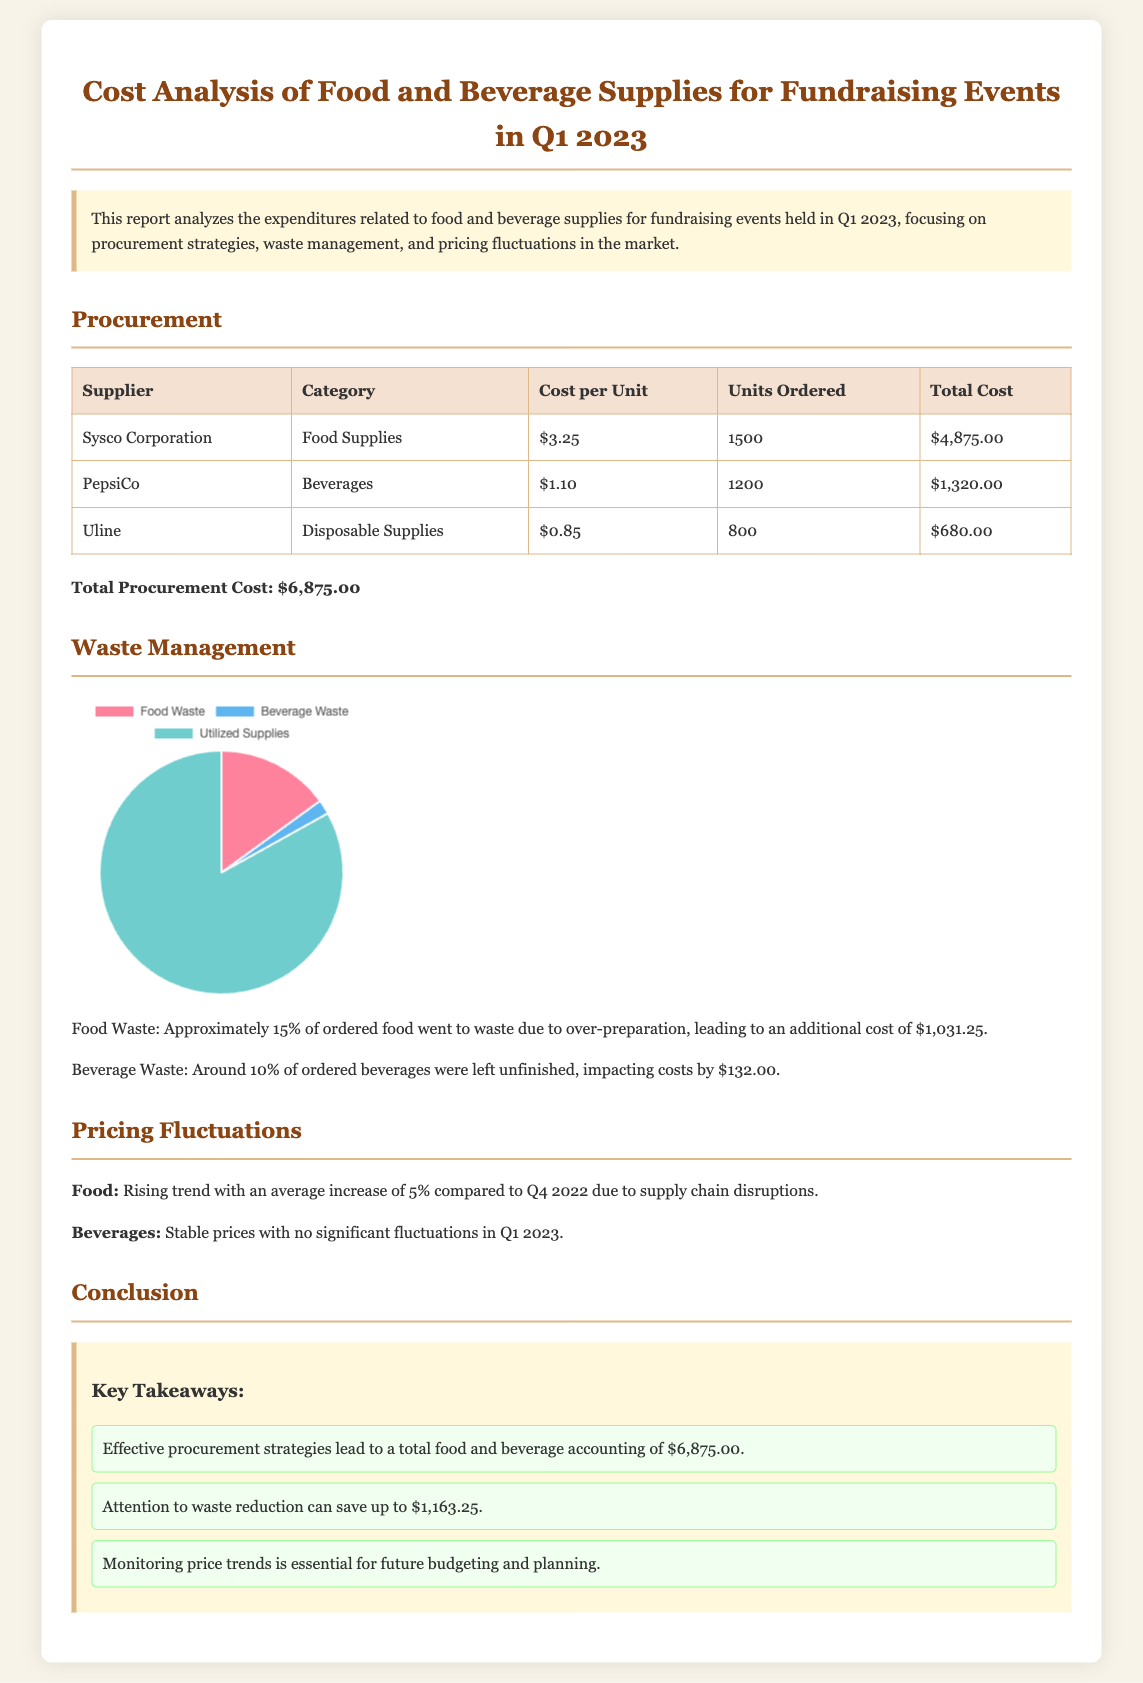What is the total procurement cost? The total procurement cost is explicitly stated in the document under the procurement section.
Answer: $6,875.00 What percentage of food went to waste? The document specifies that approximately 15% of the ordered food went to waste due to over-preparation.
Answer: 15% Who was the supplier for beverages? The document lists the supplier for beverages, which is mentioned in the procurement section.
Answer: PepsiCo What is the average increase in food pricing compared to Q4 2022? The report indicates that there is a rising trend in food prices with an average increase specified.
Answer: 5% How much was lost due to food waste? The cost attributed to food waste is highlighted in the waste management section of the report.
Answer: $1,031.25 What does the waste management chart represent? The chart visually displays the distribution of food waste, beverage waste, and utilized supplies, summarizing waste management data in a graphical format.
Answer: Waste vs Utilized Supplies What is the cost of disposable supplies per unit? This cost is detailed in the procurement table for disposable supplies.
Answer: $0.85 What was the beverage waste cost? The document reports the cost associated with beverage waste in the waste management section.
Answer: $132.00 